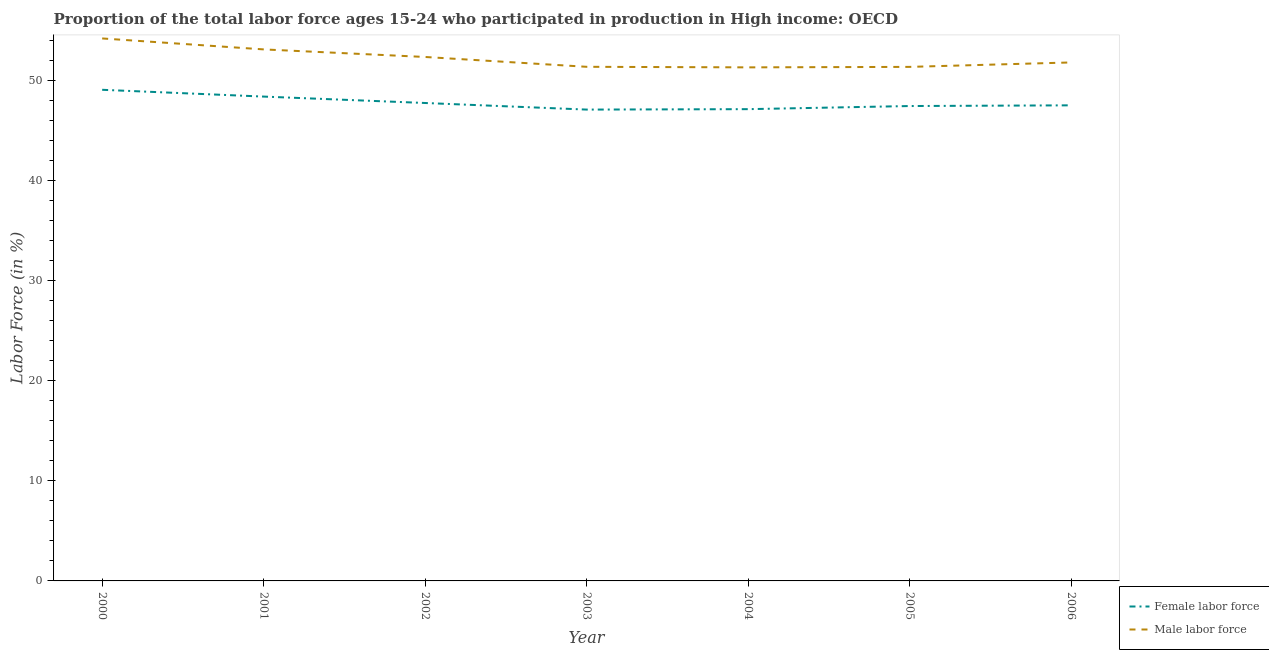How many different coloured lines are there?
Offer a very short reply. 2. Does the line corresponding to percentage of female labor force intersect with the line corresponding to percentage of male labour force?
Make the answer very short. No. What is the percentage of male labour force in 2000?
Ensure brevity in your answer.  54.19. Across all years, what is the maximum percentage of male labour force?
Your answer should be very brief. 54.19. Across all years, what is the minimum percentage of female labor force?
Make the answer very short. 47.08. In which year was the percentage of male labour force minimum?
Your response must be concise. 2004. What is the total percentage of male labour force in the graph?
Your answer should be compact. 365.41. What is the difference between the percentage of male labour force in 2002 and that in 2004?
Offer a very short reply. 1.04. What is the difference between the percentage of male labour force in 2005 and the percentage of female labor force in 2002?
Offer a terse response. 3.61. What is the average percentage of female labor force per year?
Your answer should be very brief. 47.76. In the year 2001, what is the difference between the percentage of male labour force and percentage of female labor force?
Offer a terse response. 4.71. What is the ratio of the percentage of female labor force in 2000 to that in 2004?
Your answer should be compact. 1.04. What is the difference between the highest and the second highest percentage of female labor force?
Offer a terse response. 0.68. What is the difference between the highest and the lowest percentage of female labor force?
Keep it short and to the point. 1.98. In how many years, is the percentage of male labour force greater than the average percentage of male labour force taken over all years?
Make the answer very short. 3. Is the sum of the percentage of female labor force in 2001 and 2003 greater than the maximum percentage of male labour force across all years?
Provide a succinct answer. Yes. Is the percentage of male labour force strictly less than the percentage of female labor force over the years?
Offer a very short reply. No. How many lines are there?
Your response must be concise. 2. What is the title of the graph?
Provide a short and direct response. Proportion of the total labor force ages 15-24 who participated in production in High income: OECD. Does "Merchandise exports" appear as one of the legend labels in the graph?
Your answer should be compact. No. What is the label or title of the X-axis?
Keep it short and to the point. Year. What is the Labor Force (in %) in Female labor force in 2000?
Provide a short and direct response. 49.06. What is the Labor Force (in %) in Male labor force in 2000?
Make the answer very short. 54.19. What is the Labor Force (in %) in Female labor force in 2001?
Your response must be concise. 48.38. What is the Labor Force (in %) in Male labor force in 2001?
Ensure brevity in your answer.  53.09. What is the Labor Force (in %) of Female labor force in 2002?
Provide a succinct answer. 47.74. What is the Labor Force (in %) in Male labor force in 2002?
Offer a terse response. 52.34. What is the Labor Force (in %) of Female labor force in 2003?
Your response must be concise. 47.08. What is the Labor Force (in %) in Male labor force in 2003?
Give a very brief answer. 51.35. What is the Labor Force (in %) in Female labor force in 2004?
Make the answer very short. 47.12. What is the Labor Force (in %) of Male labor force in 2004?
Offer a very short reply. 51.3. What is the Labor Force (in %) of Female labor force in 2005?
Give a very brief answer. 47.44. What is the Labor Force (in %) of Male labor force in 2005?
Your answer should be very brief. 51.35. What is the Labor Force (in %) of Female labor force in 2006?
Your answer should be very brief. 47.51. What is the Labor Force (in %) of Male labor force in 2006?
Keep it short and to the point. 51.79. Across all years, what is the maximum Labor Force (in %) of Female labor force?
Give a very brief answer. 49.06. Across all years, what is the maximum Labor Force (in %) in Male labor force?
Offer a terse response. 54.19. Across all years, what is the minimum Labor Force (in %) of Female labor force?
Give a very brief answer. 47.08. Across all years, what is the minimum Labor Force (in %) in Male labor force?
Ensure brevity in your answer.  51.3. What is the total Labor Force (in %) of Female labor force in the graph?
Ensure brevity in your answer.  334.33. What is the total Labor Force (in %) in Male labor force in the graph?
Offer a very short reply. 365.41. What is the difference between the Labor Force (in %) of Female labor force in 2000 and that in 2001?
Give a very brief answer. 0.68. What is the difference between the Labor Force (in %) in Male labor force in 2000 and that in 2001?
Keep it short and to the point. 1.1. What is the difference between the Labor Force (in %) of Female labor force in 2000 and that in 2002?
Provide a short and direct response. 1.32. What is the difference between the Labor Force (in %) of Male labor force in 2000 and that in 2002?
Give a very brief answer. 1.85. What is the difference between the Labor Force (in %) of Female labor force in 2000 and that in 2003?
Provide a short and direct response. 1.98. What is the difference between the Labor Force (in %) in Male labor force in 2000 and that in 2003?
Provide a succinct answer. 2.83. What is the difference between the Labor Force (in %) of Female labor force in 2000 and that in 2004?
Give a very brief answer. 1.93. What is the difference between the Labor Force (in %) of Male labor force in 2000 and that in 2004?
Your response must be concise. 2.89. What is the difference between the Labor Force (in %) of Female labor force in 2000 and that in 2005?
Make the answer very short. 1.62. What is the difference between the Labor Force (in %) of Male labor force in 2000 and that in 2005?
Your answer should be compact. 2.84. What is the difference between the Labor Force (in %) in Female labor force in 2000 and that in 2006?
Provide a succinct answer. 1.55. What is the difference between the Labor Force (in %) of Male labor force in 2000 and that in 2006?
Keep it short and to the point. 2.4. What is the difference between the Labor Force (in %) in Female labor force in 2001 and that in 2002?
Provide a short and direct response. 0.64. What is the difference between the Labor Force (in %) in Male labor force in 2001 and that in 2002?
Keep it short and to the point. 0.76. What is the difference between the Labor Force (in %) in Female labor force in 2001 and that in 2003?
Give a very brief answer. 1.3. What is the difference between the Labor Force (in %) in Male labor force in 2001 and that in 2003?
Your response must be concise. 1.74. What is the difference between the Labor Force (in %) in Female labor force in 2001 and that in 2004?
Provide a short and direct response. 1.26. What is the difference between the Labor Force (in %) of Male labor force in 2001 and that in 2004?
Your answer should be compact. 1.79. What is the difference between the Labor Force (in %) of Female labor force in 2001 and that in 2005?
Offer a very short reply. 0.94. What is the difference between the Labor Force (in %) in Male labor force in 2001 and that in 2005?
Ensure brevity in your answer.  1.75. What is the difference between the Labor Force (in %) of Female labor force in 2001 and that in 2006?
Offer a very short reply. 0.87. What is the difference between the Labor Force (in %) in Male labor force in 2001 and that in 2006?
Your answer should be compact. 1.3. What is the difference between the Labor Force (in %) in Female labor force in 2002 and that in 2003?
Your answer should be very brief. 0.66. What is the difference between the Labor Force (in %) of Male labor force in 2002 and that in 2003?
Offer a very short reply. 0.98. What is the difference between the Labor Force (in %) of Female labor force in 2002 and that in 2004?
Offer a very short reply. 0.62. What is the difference between the Labor Force (in %) of Male labor force in 2002 and that in 2004?
Your response must be concise. 1.04. What is the difference between the Labor Force (in %) in Female labor force in 2002 and that in 2005?
Make the answer very short. 0.3. What is the difference between the Labor Force (in %) in Male labor force in 2002 and that in 2005?
Your response must be concise. 0.99. What is the difference between the Labor Force (in %) of Female labor force in 2002 and that in 2006?
Offer a very short reply. 0.23. What is the difference between the Labor Force (in %) of Male labor force in 2002 and that in 2006?
Give a very brief answer. 0.55. What is the difference between the Labor Force (in %) of Female labor force in 2003 and that in 2004?
Offer a very short reply. -0.04. What is the difference between the Labor Force (in %) in Male labor force in 2003 and that in 2004?
Offer a terse response. 0.06. What is the difference between the Labor Force (in %) of Female labor force in 2003 and that in 2005?
Your answer should be compact. -0.35. What is the difference between the Labor Force (in %) in Male labor force in 2003 and that in 2005?
Your answer should be compact. 0.01. What is the difference between the Labor Force (in %) of Female labor force in 2003 and that in 2006?
Ensure brevity in your answer.  -0.42. What is the difference between the Labor Force (in %) of Male labor force in 2003 and that in 2006?
Give a very brief answer. -0.44. What is the difference between the Labor Force (in %) in Female labor force in 2004 and that in 2005?
Your answer should be compact. -0.31. What is the difference between the Labor Force (in %) of Male labor force in 2004 and that in 2005?
Keep it short and to the point. -0.05. What is the difference between the Labor Force (in %) in Female labor force in 2004 and that in 2006?
Offer a terse response. -0.38. What is the difference between the Labor Force (in %) of Male labor force in 2004 and that in 2006?
Give a very brief answer. -0.49. What is the difference between the Labor Force (in %) of Female labor force in 2005 and that in 2006?
Offer a terse response. -0.07. What is the difference between the Labor Force (in %) in Male labor force in 2005 and that in 2006?
Your answer should be compact. -0.44. What is the difference between the Labor Force (in %) of Female labor force in 2000 and the Labor Force (in %) of Male labor force in 2001?
Keep it short and to the point. -4.04. What is the difference between the Labor Force (in %) in Female labor force in 2000 and the Labor Force (in %) in Male labor force in 2002?
Give a very brief answer. -3.28. What is the difference between the Labor Force (in %) of Female labor force in 2000 and the Labor Force (in %) of Male labor force in 2003?
Provide a succinct answer. -2.3. What is the difference between the Labor Force (in %) in Female labor force in 2000 and the Labor Force (in %) in Male labor force in 2004?
Ensure brevity in your answer.  -2.24. What is the difference between the Labor Force (in %) of Female labor force in 2000 and the Labor Force (in %) of Male labor force in 2005?
Your response must be concise. -2.29. What is the difference between the Labor Force (in %) in Female labor force in 2000 and the Labor Force (in %) in Male labor force in 2006?
Provide a short and direct response. -2.73. What is the difference between the Labor Force (in %) in Female labor force in 2001 and the Labor Force (in %) in Male labor force in 2002?
Ensure brevity in your answer.  -3.96. What is the difference between the Labor Force (in %) in Female labor force in 2001 and the Labor Force (in %) in Male labor force in 2003?
Your answer should be compact. -2.97. What is the difference between the Labor Force (in %) of Female labor force in 2001 and the Labor Force (in %) of Male labor force in 2004?
Offer a terse response. -2.92. What is the difference between the Labor Force (in %) in Female labor force in 2001 and the Labor Force (in %) in Male labor force in 2005?
Provide a short and direct response. -2.97. What is the difference between the Labor Force (in %) in Female labor force in 2001 and the Labor Force (in %) in Male labor force in 2006?
Provide a succinct answer. -3.41. What is the difference between the Labor Force (in %) in Female labor force in 2002 and the Labor Force (in %) in Male labor force in 2003?
Your answer should be compact. -3.61. What is the difference between the Labor Force (in %) in Female labor force in 2002 and the Labor Force (in %) in Male labor force in 2004?
Offer a very short reply. -3.56. What is the difference between the Labor Force (in %) in Female labor force in 2002 and the Labor Force (in %) in Male labor force in 2005?
Provide a succinct answer. -3.61. What is the difference between the Labor Force (in %) of Female labor force in 2002 and the Labor Force (in %) of Male labor force in 2006?
Offer a terse response. -4.05. What is the difference between the Labor Force (in %) of Female labor force in 2003 and the Labor Force (in %) of Male labor force in 2004?
Offer a terse response. -4.22. What is the difference between the Labor Force (in %) of Female labor force in 2003 and the Labor Force (in %) of Male labor force in 2005?
Give a very brief answer. -4.27. What is the difference between the Labor Force (in %) of Female labor force in 2003 and the Labor Force (in %) of Male labor force in 2006?
Keep it short and to the point. -4.71. What is the difference between the Labor Force (in %) of Female labor force in 2004 and the Labor Force (in %) of Male labor force in 2005?
Provide a succinct answer. -4.22. What is the difference between the Labor Force (in %) of Female labor force in 2004 and the Labor Force (in %) of Male labor force in 2006?
Offer a very short reply. -4.67. What is the difference between the Labor Force (in %) in Female labor force in 2005 and the Labor Force (in %) in Male labor force in 2006?
Provide a short and direct response. -4.35. What is the average Labor Force (in %) of Female labor force per year?
Provide a short and direct response. 47.76. What is the average Labor Force (in %) in Male labor force per year?
Provide a short and direct response. 52.2. In the year 2000, what is the difference between the Labor Force (in %) of Female labor force and Labor Force (in %) of Male labor force?
Provide a short and direct response. -5.13. In the year 2001, what is the difference between the Labor Force (in %) of Female labor force and Labor Force (in %) of Male labor force?
Make the answer very short. -4.71. In the year 2002, what is the difference between the Labor Force (in %) in Female labor force and Labor Force (in %) in Male labor force?
Offer a very short reply. -4.6. In the year 2003, what is the difference between the Labor Force (in %) of Female labor force and Labor Force (in %) of Male labor force?
Offer a very short reply. -4.27. In the year 2004, what is the difference between the Labor Force (in %) in Female labor force and Labor Force (in %) in Male labor force?
Your answer should be very brief. -4.17. In the year 2005, what is the difference between the Labor Force (in %) in Female labor force and Labor Force (in %) in Male labor force?
Your answer should be very brief. -3.91. In the year 2006, what is the difference between the Labor Force (in %) of Female labor force and Labor Force (in %) of Male labor force?
Your answer should be very brief. -4.28. What is the ratio of the Labor Force (in %) of Female labor force in 2000 to that in 2001?
Your answer should be very brief. 1.01. What is the ratio of the Labor Force (in %) in Male labor force in 2000 to that in 2001?
Keep it short and to the point. 1.02. What is the ratio of the Labor Force (in %) of Female labor force in 2000 to that in 2002?
Provide a succinct answer. 1.03. What is the ratio of the Labor Force (in %) in Male labor force in 2000 to that in 2002?
Your answer should be compact. 1.04. What is the ratio of the Labor Force (in %) of Female labor force in 2000 to that in 2003?
Keep it short and to the point. 1.04. What is the ratio of the Labor Force (in %) in Male labor force in 2000 to that in 2003?
Provide a short and direct response. 1.06. What is the ratio of the Labor Force (in %) of Female labor force in 2000 to that in 2004?
Your answer should be compact. 1.04. What is the ratio of the Labor Force (in %) in Male labor force in 2000 to that in 2004?
Ensure brevity in your answer.  1.06. What is the ratio of the Labor Force (in %) in Female labor force in 2000 to that in 2005?
Provide a short and direct response. 1.03. What is the ratio of the Labor Force (in %) of Male labor force in 2000 to that in 2005?
Keep it short and to the point. 1.06. What is the ratio of the Labor Force (in %) of Female labor force in 2000 to that in 2006?
Your answer should be compact. 1.03. What is the ratio of the Labor Force (in %) in Male labor force in 2000 to that in 2006?
Ensure brevity in your answer.  1.05. What is the ratio of the Labor Force (in %) in Female labor force in 2001 to that in 2002?
Provide a succinct answer. 1.01. What is the ratio of the Labor Force (in %) in Male labor force in 2001 to that in 2002?
Ensure brevity in your answer.  1.01. What is the ratio of the Labor Force (in %) in Female labor force in 2001 to that in 2003?
Your answer should be compact. 1.03. What is the ratio of the Labor Force (in %) in Male labor force in 2001 to that in 2003?
Your answer should be compact. 1.03. What is the ratio of the Labor Force (in %) of Female labor force in 2001 to that in 2004?
Your answer should be very brief. 1.03. What is the ratio of the Labor Force (in %) of Male labor force in 2001 to that in 2004?
Your answer should be very brief. 1.03. What is the ratio of the Labor Force (in %) in Female labor force in 2001 to that in 2005?
Make the answer very short. 1.02. What is the ratio of the Labor Force (in %) in Male labor force in 2001 to that in 2005?
Offer a very short reply. 1.03. What is the ratio of the Labor Force (in %) of Female labor force in 2001 to that in 2006?
Keep it short and to the point. 1.02. What is the ratio of the Labor Force (in %) in Male labor force in 2001 to that in 2006?
Ensure brevity in your answer.  1.03. What is the ratio of the Labor Force (in %) in Female labor force in 2002 to that in 2003?
Your answer should be very brief. 1.01. What is the ratio of the Labor Force (in %) of Male labor force in 2002 to that in 2003?
Provide a succinct answer. 1.02. What is the ratio of the Labor Force (in %) of Female labor force in 2002 to that in 2004?
Offer a very short reply. 1.01. What is the ratio of the Labor Force (in %) in Male labor force in 2002 to that in 2004?
Ensure brevity in your answer.  1.02. What is the ratio of the Labor Force (in %) of Female labor force in 2002 to that in 2005?
Make the answer very short. 1.01. What is the ratio of the Labor Force (in %) of Male labor force in 2002 to that in 2005?
Ensure brevity in your answer.  1.02. What is the ratio of the Labor Force (in %) in Male labor force in 2002 to that in 2006?
Your answer should be very brief. 1.01. What is the ratio of the Labor Force (in %) in Male labor force in 2003 to that in 2004?
Give a very brief answer. 1. What is the ratio of the Labor Force (in %) of Male labor force in 2003 to that in 2005?
Keep it short and to the point. 1. What is the ratio of the Labor Force (in %) in Female labor force in 2004 to that in 2005?
Your response must be concise. 0.99. What is the ratio of the Labor Force (in %) of Female labor force in 2004 to that in 2006?
Provide a short and direct response. 0.99. What is the ratio of the Labor Force (in %) in Male labor force in 2004 to that in 2006?
Your answer should be compact. 0.99. What is the ratio of the Labor Force (in %) of Female labor force in 2005 to that in 2006?
Provide a succinct answer. 1. What is the ratio of the Labor Force (in %) in Male labor force in 2005 to that in 2006?
Your response must be concise. 0.99. What is the difference between the highest and the second highest Labor Force (in %) in Female labor force?
Your answer should be compact. 0.68. What is the difference between the highest and the second highest Labor Force (in %) in Male labor force?
Give a very brief answer. 1.1. What is the difference between the highest and the lowest Labor Force (in %) in Female labor force?
Offer a terse response. 1.98. What is the difference between the highest and the lowest Labor Force (in %) of Male labor force?
Your response must be concise. 2.89. 